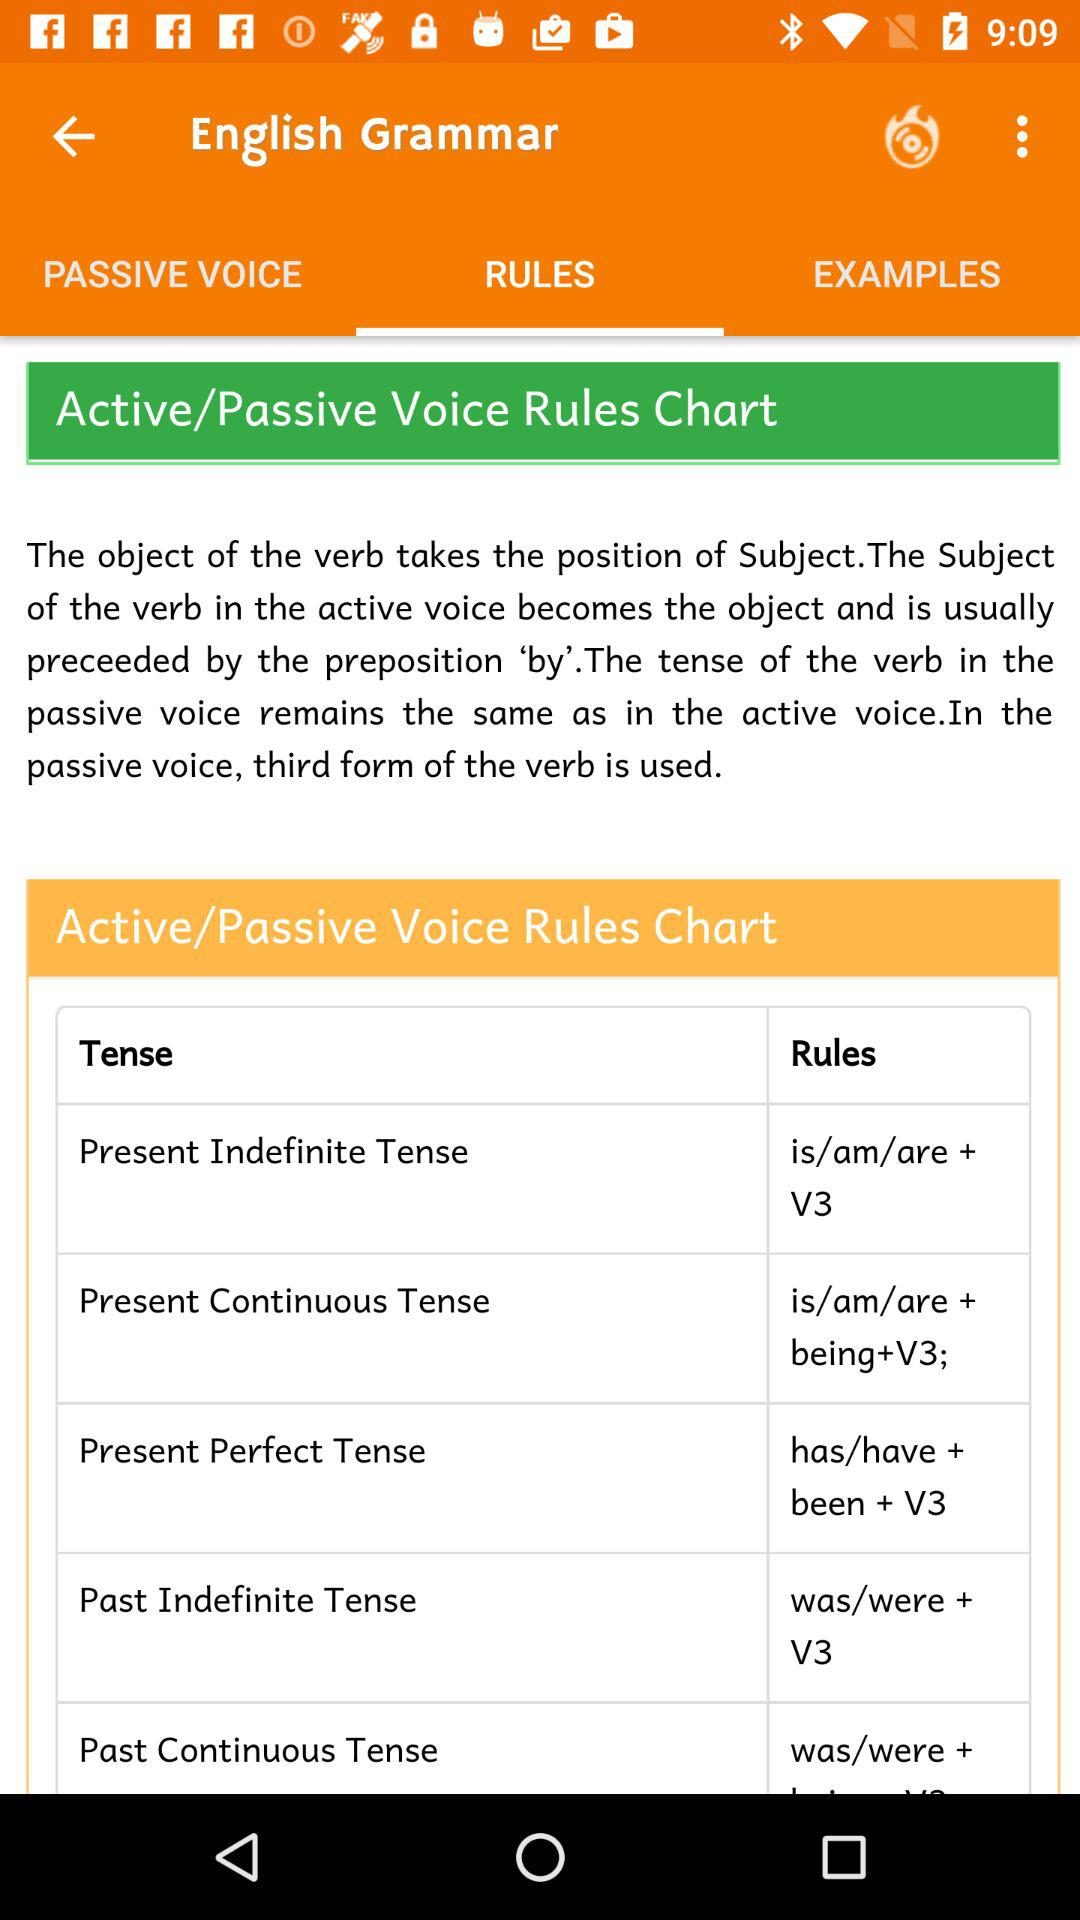Which tab am I on? You are on the "RULES" tab. 